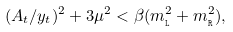Convert formula to latex. <formula><loc_0><loc_0><loc_500><loc_500>( A _ { t } / y _ { t } ) ^ { 2 } + 3 \mu ^ { 2 } < \beta ( m _ { \tt _ { L } } ^ { 2 } + m _ { \tt _ { R } } ^ { 2 } ) ,</formula> 